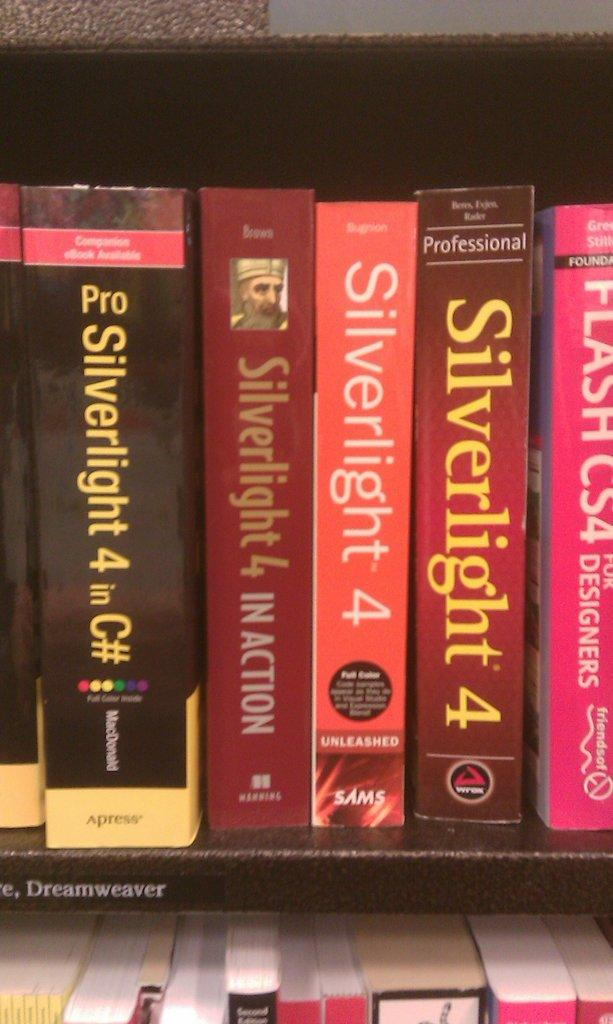<image>
Create a compact narrative representing the image presented. Several books on the same subject, called Silverlight 4. 